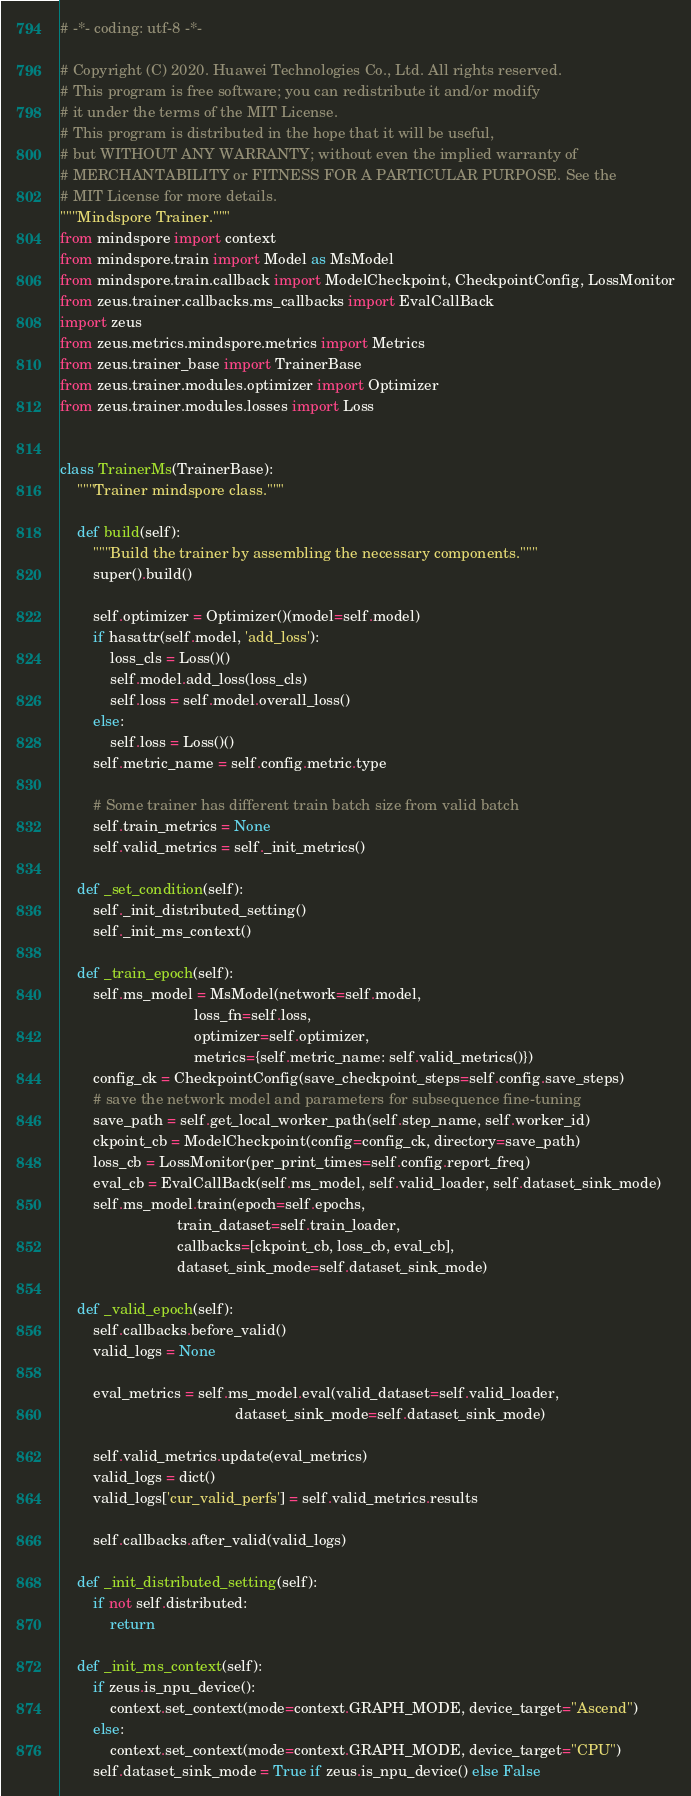<code> <loc_0><loc_0><loc_500><loc_500><_Python_># -*- coding: utf-8 -*-

# Copyright (C) 2020. Huawei Technologies Co., Ltd. All rights reserved.
# This program is free software; you can redistribute it and/or modify
# it under the terms of the MIT License.
# This program is distributed in the hope that it will be useful,
# but WITHOUT ANY WARRANTY; without even the implied warranty of
# MERCHANTABILITY or FITNESS FOR A PARTICULAR PURPOSE. See the
# MIT License for more details.
"""Mindspore Trainer."""
from mindspore import context
from mindspore.train import Model as MsModel
from mindspore.train.callback import ModelCheckpoint, CheckpointConfig, LossMonitor
from zeus.trainer.callbacks.ms_callbacks import EvalCallBack
import zeus
from zeus.metrics.mindspore.metrics import Metrics
from zeus.trainer_base import TrainerBase
from zeus.trainer.modules.optimizer import Optimizer
from zeus.trainer.modules.losses import Loss


class TrainerMs(TrainerBase):
    """Trainer mindspore class."""

    def build(self):
        """Build the trainer by assembling the necessary components."""
        super().build()

        self.optimizer = Optimizer()(model=self.model)
        if hasattr(self.model, 'add_loss'):
            loss_cls = Loss()()
            self.model.add_loss(loss_cls)
            self.loss = self.model.overall_loss()
        else:
            self.loss = Loss()()
        self.metric_name = self.config.metric.type

        # Some trainer has different train batch size from valid batch
        self.train_metrics = None
        self.valid_metrics = self._init_metrics()

    def _set_condition(self):
        self._init_distributed_setting()
        self._init_ms_context()

    def _train_epoch(self):
        self.ms_model = MsModel(network=self.model,
                                loss_fn=self.loss,
                                optimizer=self.optimizer,
                                metrics={self.metric_name: self.valid_metrics()})
        config_ck = CheckpointConfig(save_checkpoint_steps=self.config.save_steps)
        # save the network model and parameters for subsequence fine-tuning
        save_path = self.get_local_worker_path(self.step_name, self.worker_id)
        ckpoint_cb = ModelCheckpoint(config=config_ck, directory=save_path)
        loss_cb = LossMonitor(per_print_times=self.config.report_freq)
        eval_cb = EvalCallBack(self.ms_model, self.valid_loader, self.dataset_sink_mode)
        self.ms_model.train(epoch=self.epochs,
                            train_dataset=self.train_loader,
                            callbacks=[ckpoint_cb, loss_cb, eval_cb],
                            dataset_sink_mode=self.dataset_sink_mode)

    def _valid_epoch(self):
        self.callbacks.before_valid()
        valid_logs = None

        eval_metrics = self.ms_model.eval(valid_dataset=self.valid_loader,
                                          dataset_sink_mode=self.dataset_sink_mode)

        self.valid_metrics.update(eval_metrics)
        valid_logs = dict()
        valid_logs['cur_valid_perfs'] = self.valid_metrics.results

        self.callbacks.after_valid(valid_logs)

    def _init_distributed_setting(self):
        if not self.distributed:
            return

    def _init_ms_context(self):
        if zeus.is_npu_device():
            context.set_context(mode=context.GRAPH_MODE, device_target="Ascend")
        else:
            context.set_context(mode=context.GRAPH_MODE, device_target="CPU")
        self.dataset_sink_mode = True if zeus.is_npu_device() else False
</code> 